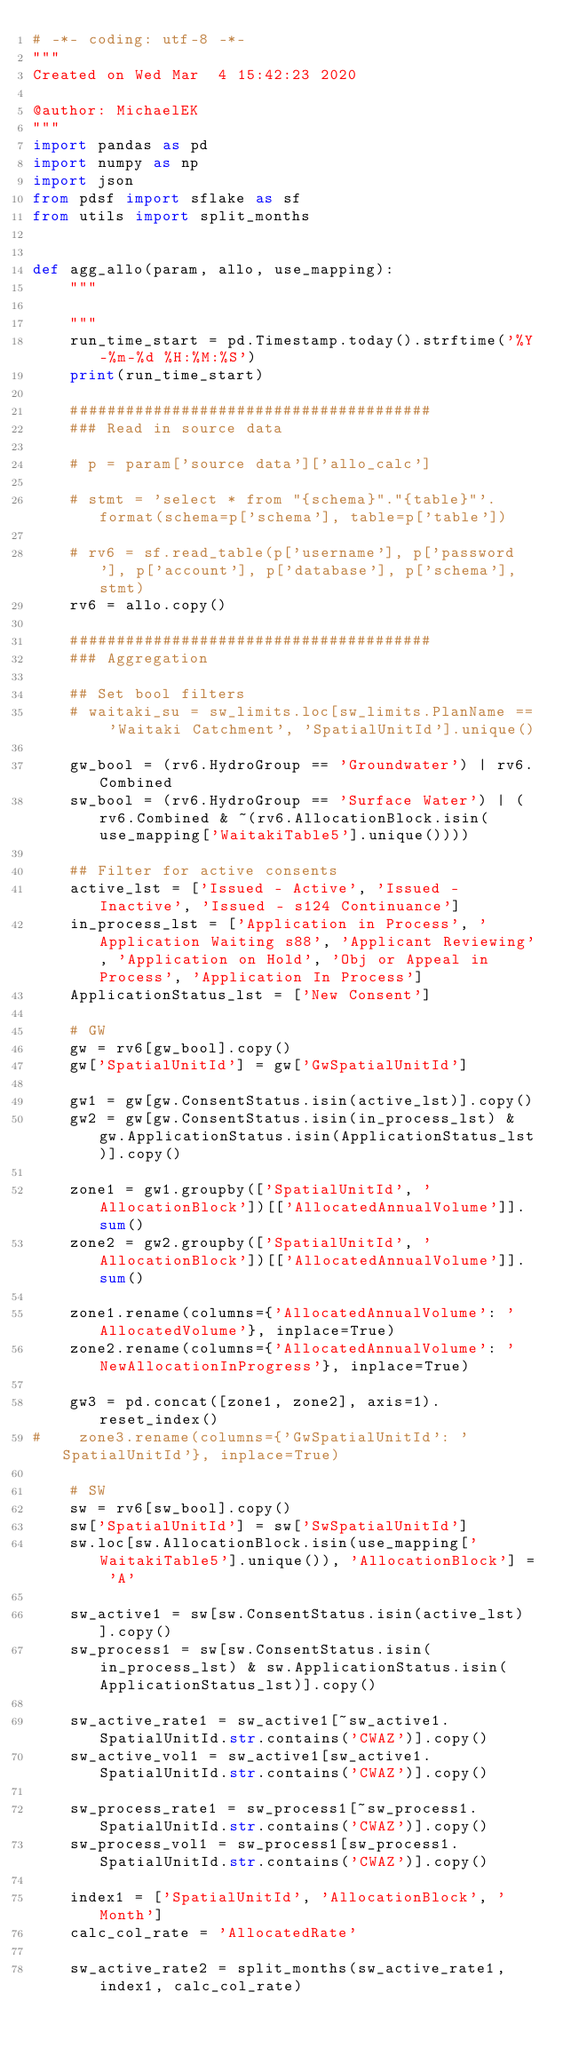<code> <loc_0><loc_0><loc_500><loc_500><_Python_># -*- coding: utf-8 -*-
"""
Created on Wed Mar  4 15:42:23 2020

@author: MichaelEK
"""
import pandas as pd
import numpy as np
import json
from pdsf import sflake as sf
from utils import split_months


def agg_allo(param, allo, use_mapping):
    """

    """
    run_time_start = pd.Timestamp.today().strftime('%Y-%m-%d %H:%M:%S')
    print(run_time_start)

    #######################################
    ### Read in source data

    # p = param['source data']['allo_calc']

    # stmt = 'select * from "{schema}"."{table}"'.format(schema=p['schema'], table=p['table'])

    # rv6 = sf.read_table(p['username'], p['password'], p['account'], p['database'], p['schema'], stmt)
    rv6 = allo.copy()

    #######################################
    ### Aggregation

    ## Set bool filters
    # waitaki_su = sw_limits.loc[sw_limits.PlanName == 'Waitaki Catchment', 'SpatialUnitId'].unique()

    gw_bool = (rv6.HydroGroup == 'Groundwater') | rv6.Combined
    sw_bool = (rv6.HydroGroup == 'Surface Water') | (rv6.Combined & ~(rv6.AllocationBlock.isin(use_mapping['WaitakiTable5'].unique())))

    ## Filter for active consents
    active_lst = ['Issued - Active', 'Issued - Inactive', 'Issued - s124 Continuance']
    in_process_lst = ['Application in Process', 'Application Waiting s88', 'Applicant Reviewing', 'Application on Hold', 'Obj or Appeal in Process', 'Application In Process']
    ApplicationStatus_lst = ['New Consent']

    # GW
    gw = rv6[gw_bool].copy()
    gw['SpatialUnitId'] = gw['GwSpatialUnitId']

    gw1 = gw[gw.ConsentStatus.isin(active_lst)].copy()
    gw2 = gw[gw.ConsentStatus.isin(in_process_lst) & gw.ApplicationStatus.isin(ApplicationStatus_lst)].copy()

    zone1 = gw1.groupby(['SpatialUnitId', 'AllocationBlock'])[['AllocatedAnnualVolume']].sum()
    zone2 = gw2.groupby(['SpatialUnitId', 'AllocationBlock'])[['AllocatedAnnualVolume']].sum()

    zone1.rename(columns={'AllocatedAnnualVolume': 'AllocatedVolume'}, inplace=True)
    zone2.rename(columns={'AllocatedAnnualVolume': 'NewAllocationInProgress'}, inplace=True)

    gw3 = pd.concat([zone1, zone2], axis=1).reset_index()
#    zone3.rename(columns={'GwSpatialUnitId': 'SpatialUnitId'}, inplace=True)

    # SW
    sw = rv6[sw_bool].copy()
    sw['SpatialUnitId'] = sw['SwSpatialUnitId']
    sw.loc[sw.AllocationBlock.isin(use_mapping['WaitakiTable5'].unique()), 'AllocationBlock'] = 'A'

    sw_active1 = sw[sw.ConsentStatus.isin(active_lst)].copy()
    sw_process1 = sw[sw.ConsentStatus.isin(in_process_lst) & sw.ApplicationStatus.isin(ApplicationStatus_lst)].copy()

    sw_active_rate1 = sw_active1[~sw_active1.SpatialUnitId.str.contains('CWAZ')].copy()
    sw_active_vol1 = sw_active1[sw_active1.SpatialUnitId.str.contains('CWAZ')].copy()

    sw_process_rate1 = sw_process1[~sw_process1.SpatialUnitId.str.contains('CWAZ')].copy()
    sw_process_vol1 = sw_process1[sw_process1.SpatialUnitId.str.contains('CWAZ')].copy()

    index1 = ['SpatialUnitId', 'AllocationBlock', 'Month']
    calc_col_rate = 'AllocatedRate'

    sw_active_rate2 = split_months(sw_active_rate1, index1, calc_col_rate)</code> 